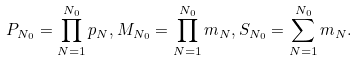<formula> <loc_0><loc_0><loc_500><loc_500>P _ { N _ { 0 } } = \prod _ { N = 1 } ^ { N _ { 0 } } p _ { N } , M _ { N _ { 0 } } = \prod _ { N = 1 } ^ { N _ { 0 } } m _ { N } , S _ { N _ { 0 } } = \sum _ { N = 1 } ^ { N _ { 0 } } m _ { N } .</formula> 